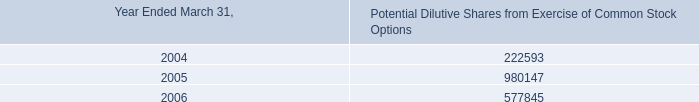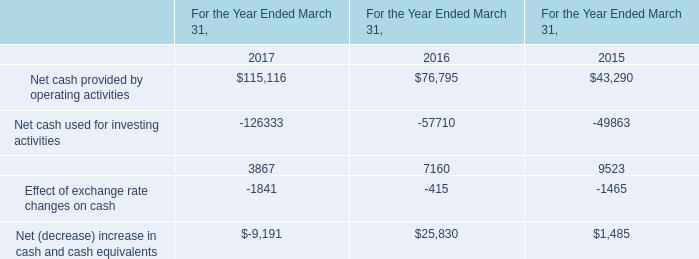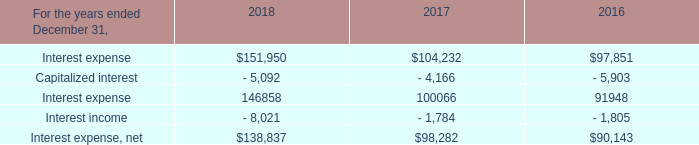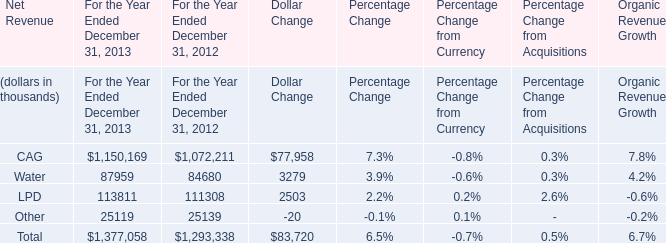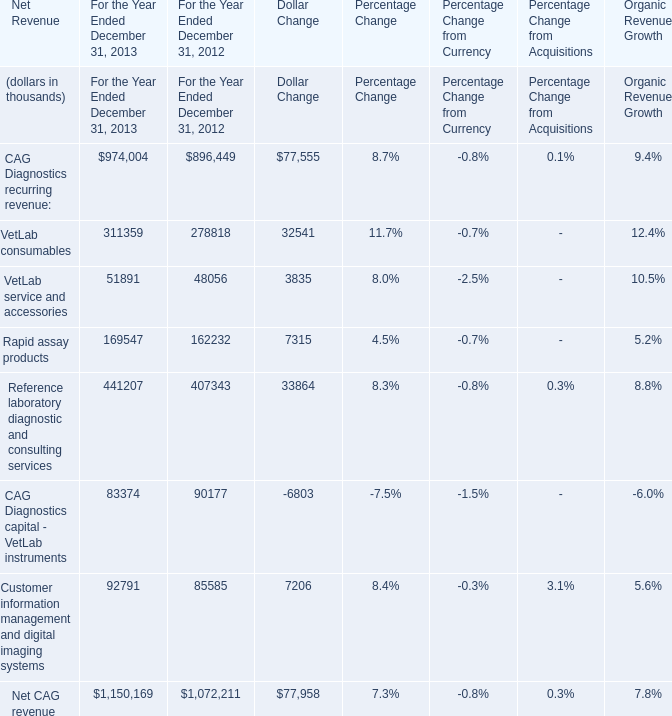Which year is VetLab consumables greater than 0 ? 
Answer: 2012,2013. 